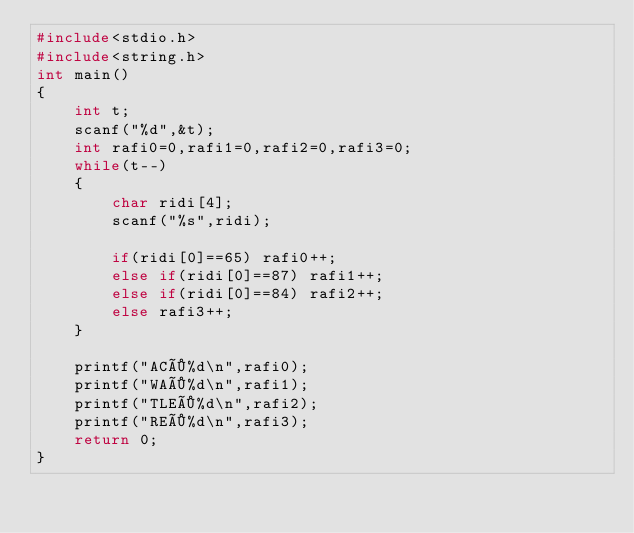Convert code to text. <code><loc_0><loc_0><loc_500><loc_500><_C_>#include<stdio.h>
#include<string.h>
int main()
{
	int t;
	scanf("%d",&t);
	int rafi0=0,rafi1=0,rafi2=0,rafi3=0;
	while(t--)
	{
		char ridi[4];
		scanf("%s",ridi);
		
		if(ridi[0]==65) rafi0++;
		else if(ridi[0]==87) rafi1++;
		else if(ridi[0]==84) rafi2++;
		else rafi3++;
	}
	
	printf("AC×%d\n",rafi0);
	printf("WA×%d\n",rafi1);
	printf("TLE×%d\n",rafi2);
	printf("RE×%d\n",rafi3);
	return 0;
}
	</code> 